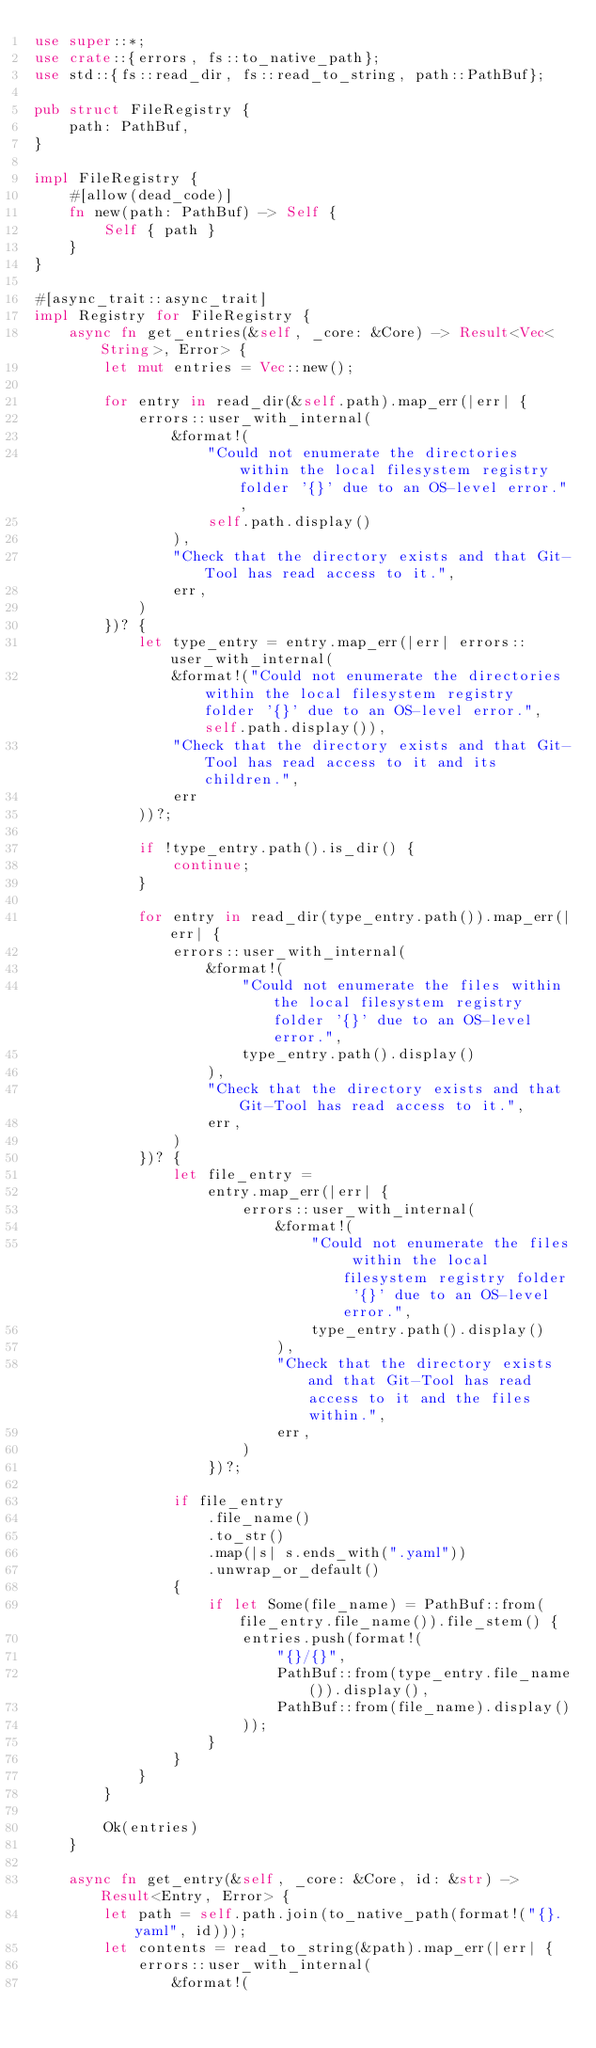Convert code to text. <code><loc_0><loc_0><loc_500><loc_500><_Rust_>use super::*;
use crate::{errors, fs::to_native_path};
use std::{fs::read_dir, fs::read_to_string, path::PathBuf};

pub struct FileRegistry {
    path: PathBuf,
}

impl FileRegistry {
    #[allow(dead_code)]
    fn new(path: PathBuf) -> Self {
        Self { path }
    }
}

#[async_trait::async_trait]
impl Registry for FileRegistry {
    async fn get_entries(&self, _core: &Core) -> Result<Vec<String>, Error> {
        let mut entries = Vec::new();

        for entry in read_dir(&self.path).map_err(|err| {
            errors::user_with_internal(
                &format!(
                    "Could not enumerate the directories within the local filesystem registry folder '{}' due to an OS-level error.",
                    self.path.display()
                ),
                "Check that the directory exists and that Git-Tool has read access to it.",
                err,
            )
        })? {
            let type_entry = entry.map_err(|err| errors::user_with_internal(
                &format!("Could not enumerate the directories within the local filesystem registry folder '{}' due to an OS-level error.", self.path.display()),
                "Check that the directory exists and that Git-Tool has read access to it and its children.",
                err
            ))?;

            if !type_entry.path().is_dir() {
                continue;
            }

            for entry in read_dir(type_entry.path()).map_err(|err| {
                errors::user_with_internal(
                    &format!(
                        "Could not enumerate the files within the local filesystem registry folder '{}' due to an OS-level error.",
                        type_entry.path().display()
                    ),
                    "Check that the directory exists and that Git-Tool has read access to it.",
                    err,
                )
            })? {
                let file_entry =
                    entry.map_err(|err| {
                        errors::user_with_internal(
                            &format!(
                                "Could not enumerate the files within the local filesystem registry folder '{}' due to an OS-level error.",
                                type_entry.path().display()
                            ),
                            "Check that the directory exists and that Git-Tool has read access to it and the files within.",
                            err,
                        )
                    })?;

                if file_entry
                    .file_name()
                    .to_str()
                    .map(|s| s.ends_with(".yaml"))
                    .unwrap_or_default()
                {
                    if let Some(file_name) = PathBuf::from(file_entry.file_name()).file_stem() {
                        entries.push(format!(
                            "{}/{}",
                            PathBuf::from(type_entry.file_name()).display(),
                            PathBuf::from(file_name).display()
                        ));
                    }
                }
            }
        }

        Ok(entries)
    }

    async fn get_entry(&self, _core: &Core, id: &str) -> Result<Entry, Error> {
        let path = self.path.join(to_native_path(format!("{}.yaml", id)));
        let contents = read_to_string(&path).map_err(|err| {
            errors::user_with_internal(
                &format!(</code> 